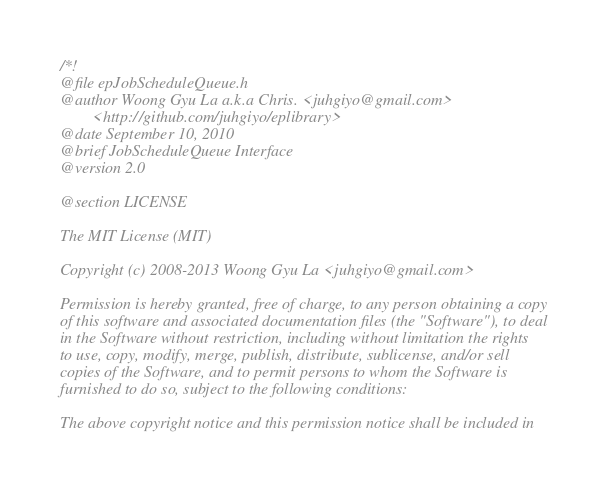Convert code to text. <code><loc_0><loc_0><loc_500><loc_500><_C_>/*! 
@file epJobScheduleQueue.h
@author Woong Gyu La a.k.a Chris. <juhgiyo@gmail.com>
		<http://github.com/juhgiyo/eplibrary>
@date September 10, 2010
@brief JobScheduleQueue Interface
@version 2.0

@section LICENSE

The MIT License (MIT)

Copyright (c) 2008-2013 Woong Gyu La <juhgiyo@gmail.com>

Permission is hereby granted, free of charge, to any person obtaining a copy
of this software and associated documentation files (the "Software"), to deal
in the Software without restriction, including without limitation the rights
to use, copy, modify, merge, publish, distribute, sublicense, and/or sell
copies of the Software, and to permit persons to whom the Software is
furnished to do so, subject to the following conditions:

The above copyright notice and this permission notice shall be included in</code> 